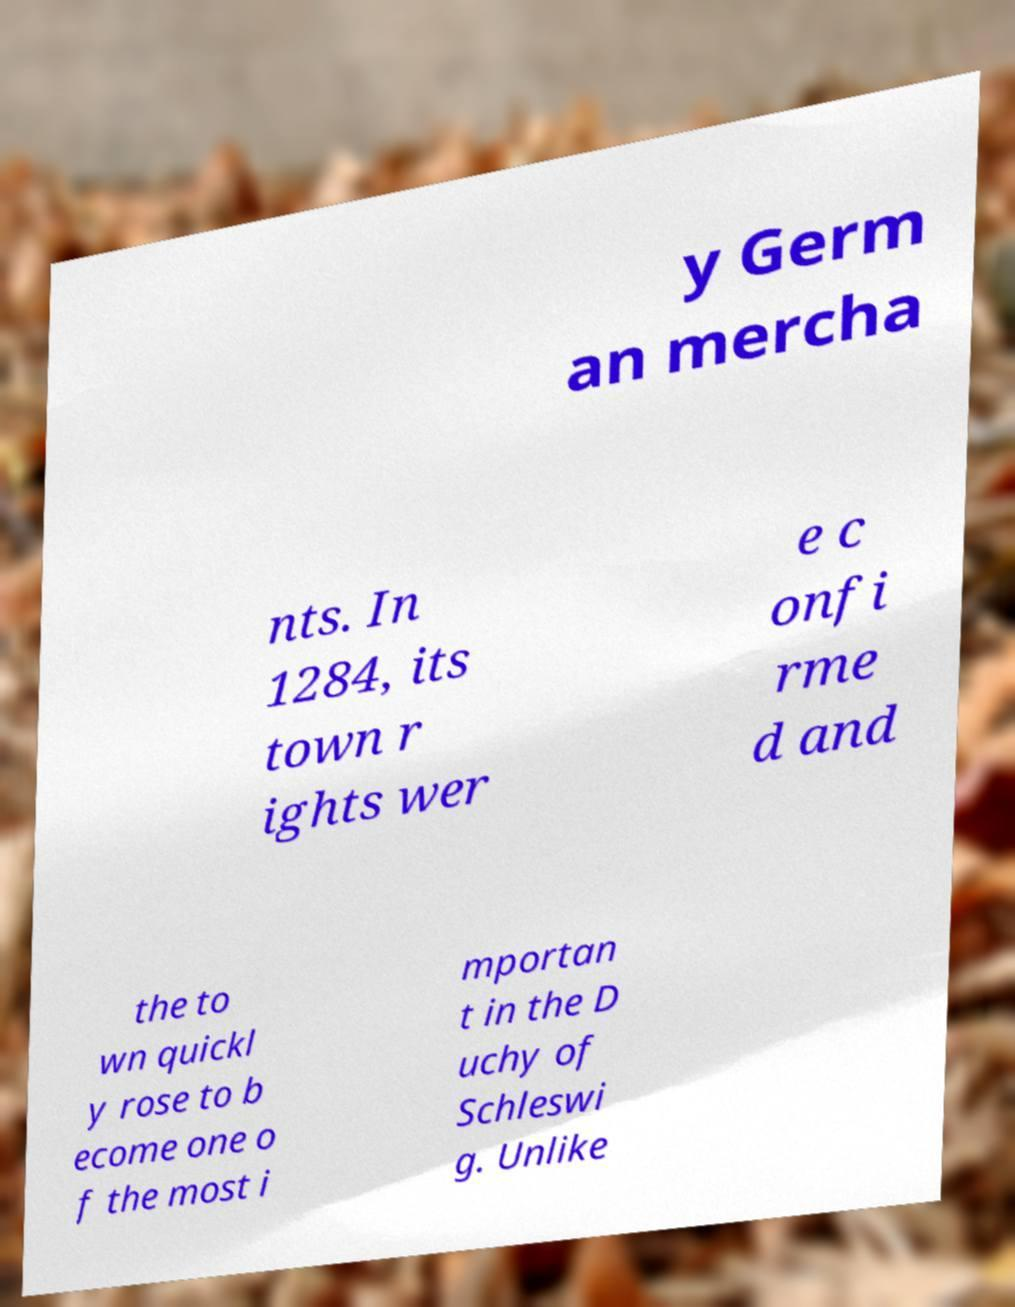Could you extract and type out the text from this image? y Germ an mercha nts. In 1284, its town r ights wer e c onfi rme d and the to wn quickl y rose to b ecome one o f the most i mportan t in the D uchy of Schleswi g. Unlike 